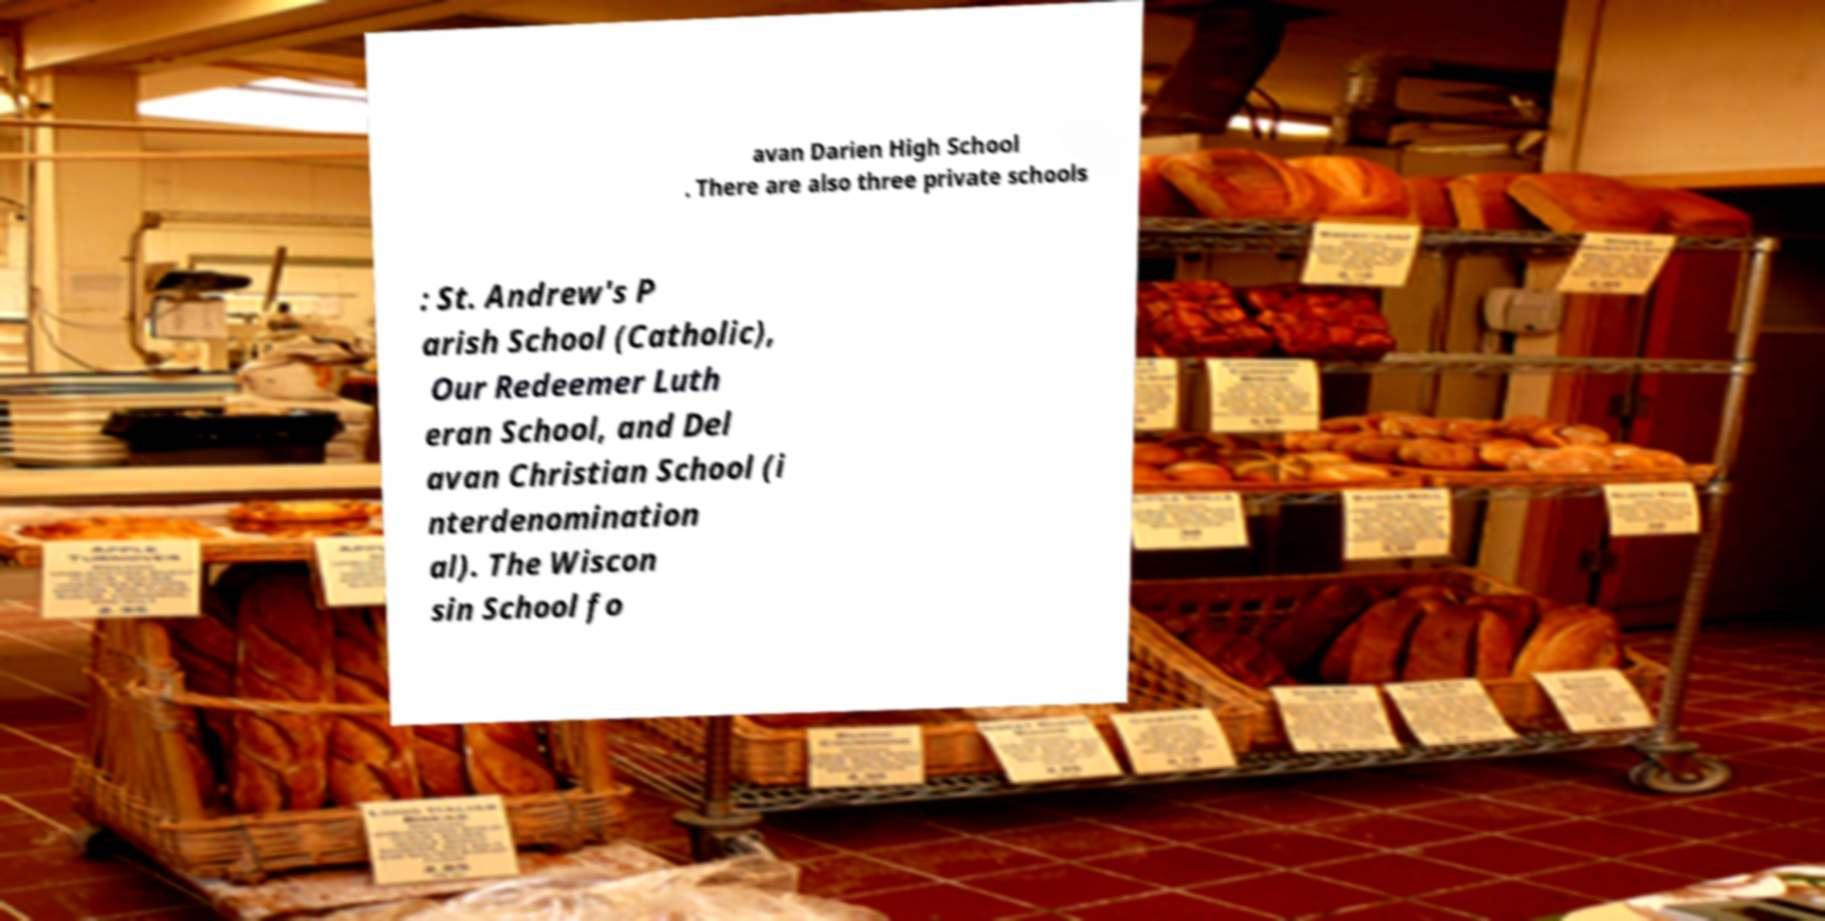There's text embedded in this image that I need extracted. Can you transcribe it verbatim? avan Darien High School . There are also three private schools : St. Andrew's P arish School (Catholic), Our Redeemer Luth eran School, and Del avan Christian School (i nterdenomination al). The Wiscon sin School fo 